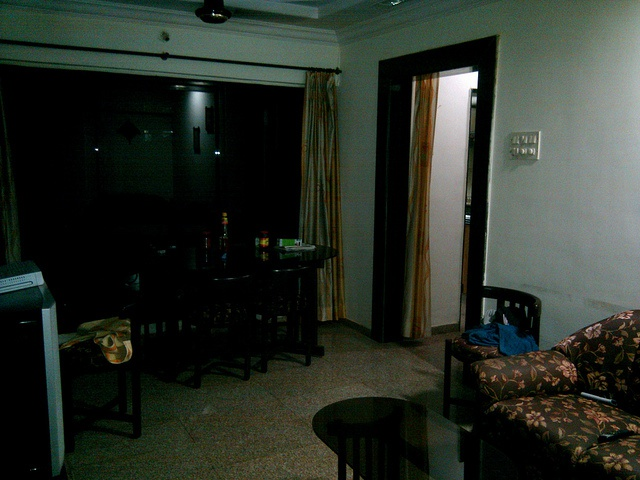Describe the objects in this image and their specific colors. I can see couch in black, maroon, olive, and gray tones, tv in black and teal tones, chair in black, navy, gray, and maroon tones, chair in black, teal, and darkgreen tones, and dining table in black, darkgreen, teal, and maroon tones in this image. 